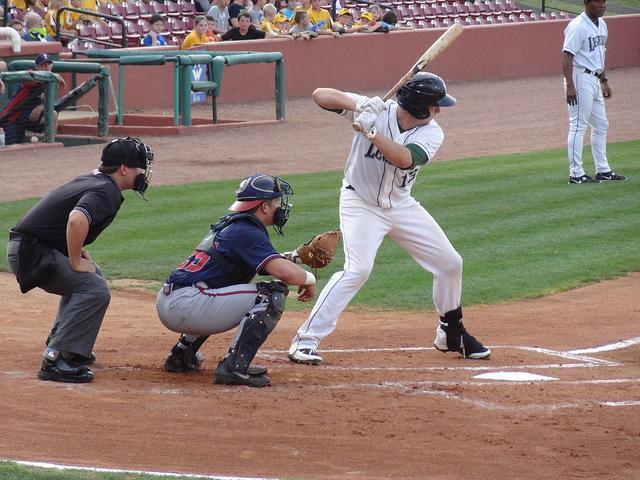How many balls?
Give a very brief answer. 0. How many people are there?
Give a very brief answer. 5. 